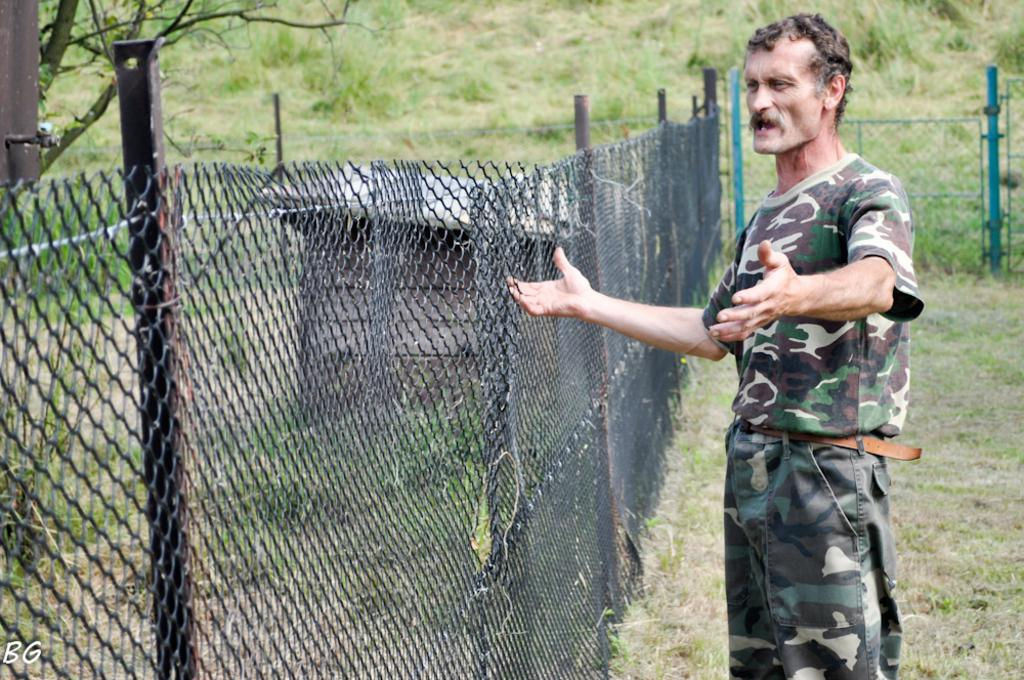What is the main subject of the image? There is a man standing in the image. What type of environment is visible in the image? There is grass, a fence, a pole, and trees visible in the image. Where is the letter 'S' located in the image? The letter 'S' is present in the bottom left corner of the image. Can you tell me how many planes are flying in the image? There are no planes visible in the image. What type of test is being conducted in the image? There is no test being conducted in the image; it simply shows a man standing in a natural environment. 